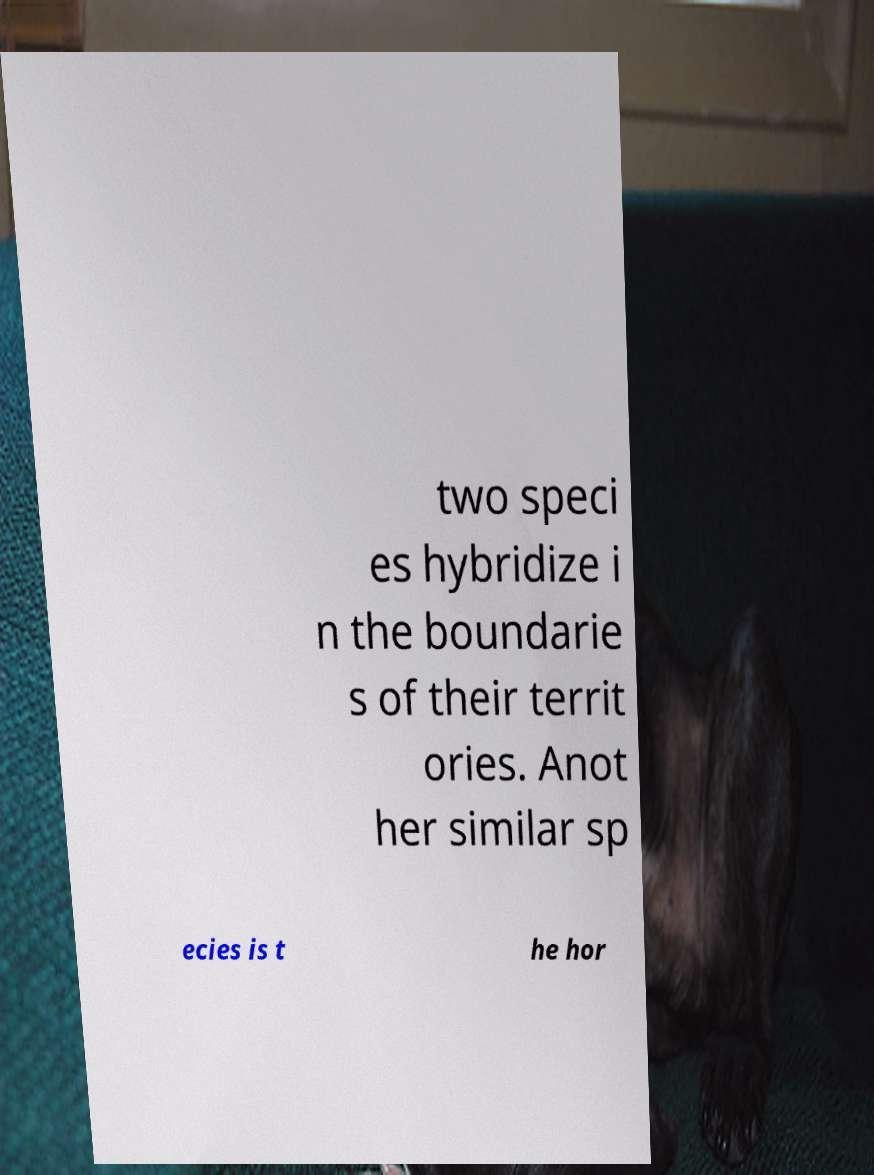Could you assist in decoding the text presented in this image and type it out clearly? two speci es hybridize i n the boundarie s of their territ ories. Anot her similar sp ecies is t he hor 